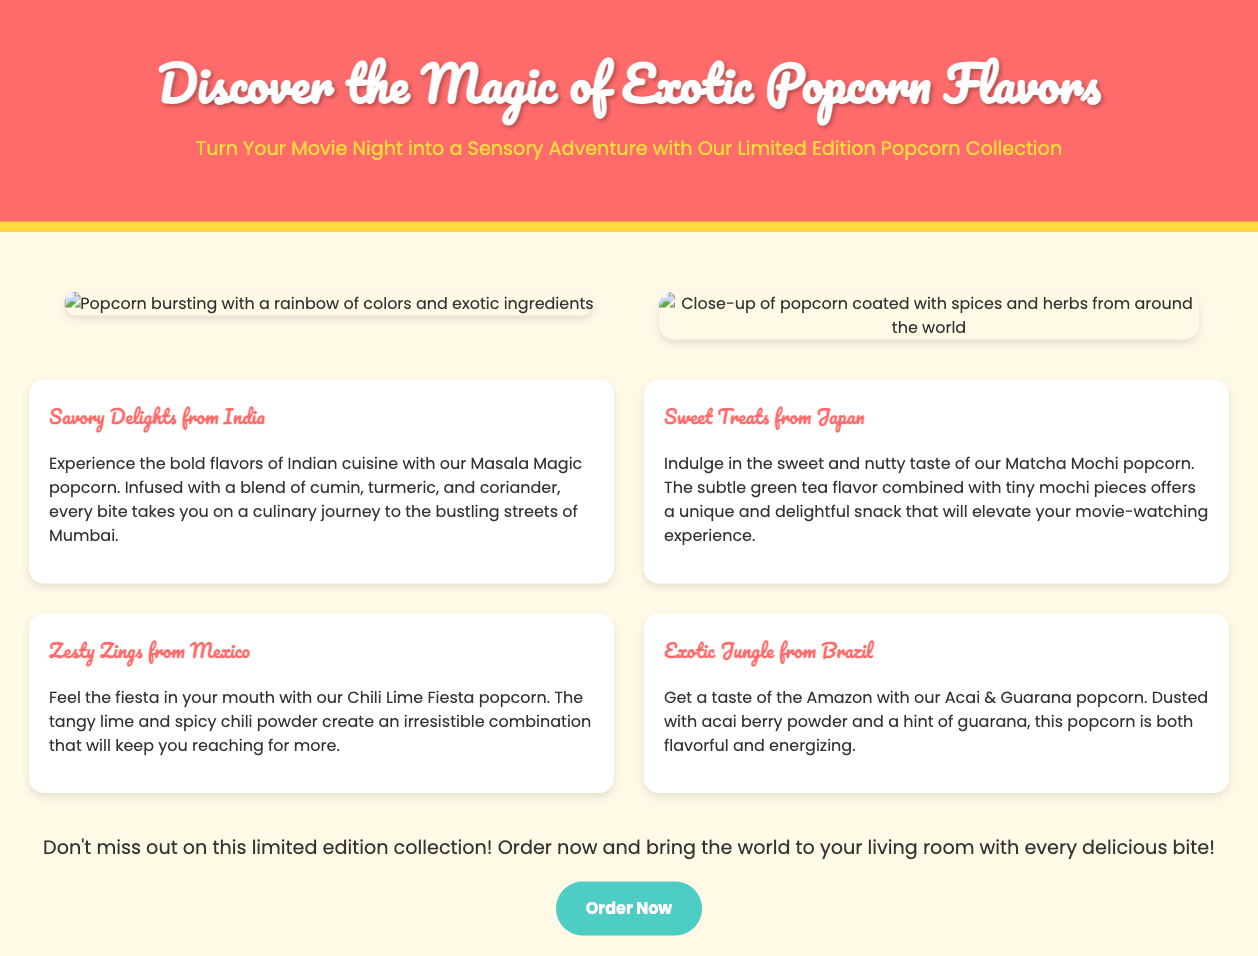What is the title of the advertisement? The title is explicitly mentioned at the beginning of the document and is "Discover the Magic of Exotic Popcorn Flavors".
Answer: Discover the Magic of Exotic Popcorn Flavors What is the tagline for the popcorn collection? The tagline is presented right below the title and reads, "Turn Your Movie Night into a Sensory Adventure with Our Limited Edition Popcorn Collection".
Answer: Turn Your Movie Night into a Sensory Adventure with Our Limited Edition Popcorn Collection How many unique popcorn flavors are mentioned in the advertisement? The document lists four unique popcorn flavors in the flavors section.
Answer: Four Which flavor features spices from India? The flavor mentioned that incorporates Indian spices is "Masala Magic".
Answer: Masala Magic What are the two main ingredients in the Acai & Guarana popcorn? The document specifies that the Acai & Guarana popcorn is dusted with acai berry powder and guarana.
Answer: Acai berry powder and guarana What is the call-to-action phrase in the advertisement? The call-to-action phrase encourages readers to "Order now and bring the world to your living room with every delicious bite!"
Answer: Order now and bring the world to your living room with every delicious bite! Which image depicts popcorn bursting with colors? The first visual item image showcases popcorn bursting with a rainbow of colors and exotic ingredients.
Answer: Popcorn bursting with a rainbow of colors What is the color theme of the advertisement? The dominant colors in the advertisement are primarily soft pastel like yellow and pink, highlighted with white text.
Answer: Soft pastel colors like yellow and pink What is the website link to order the popcorn collection? The link to order the collection is given in the call-to-action section and is "https://example.com/exotic_popcorn_collection".
Answer: https://example.com/exotic_popcorn_collection 